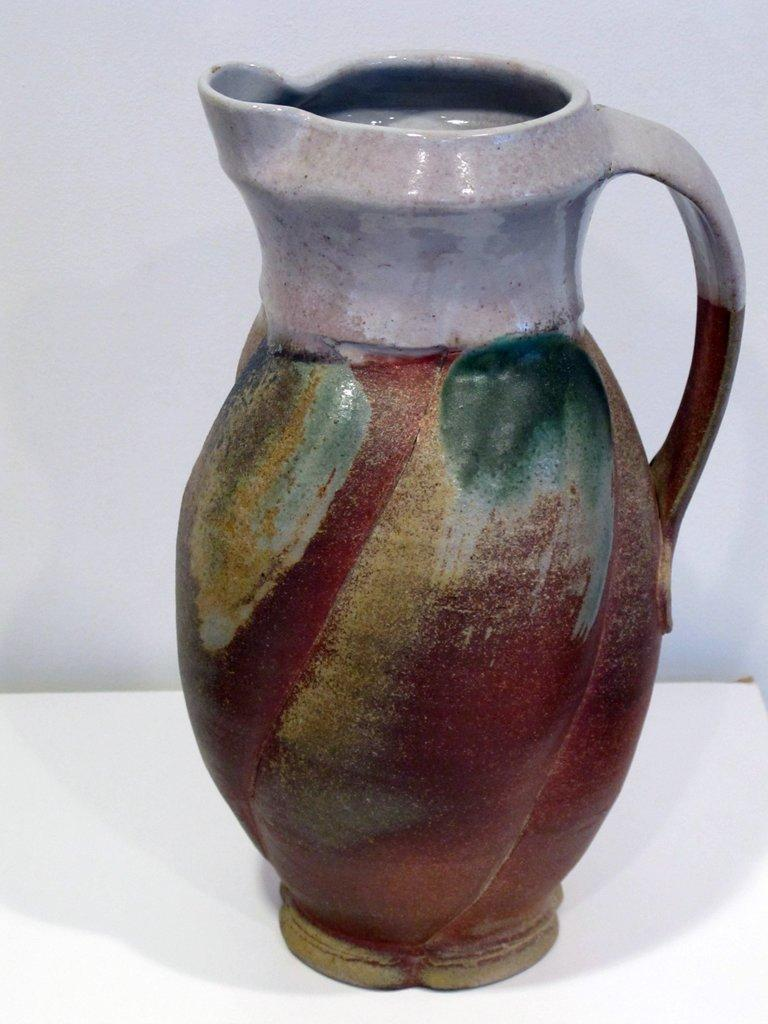What object can be seen in the image? There is a flower vase in the image. What colors are used for the flower vase? The flower vase is in brown and ash color. What type of jeans is the flower vase wearing in the image? There are no jeans present in the image, as the flower vase is an inanimate object and does not wear clothing. 